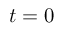Convert formula to latex. <formula><loc_0><loc_0><loc_500><loc_500>t = 0</formula> 